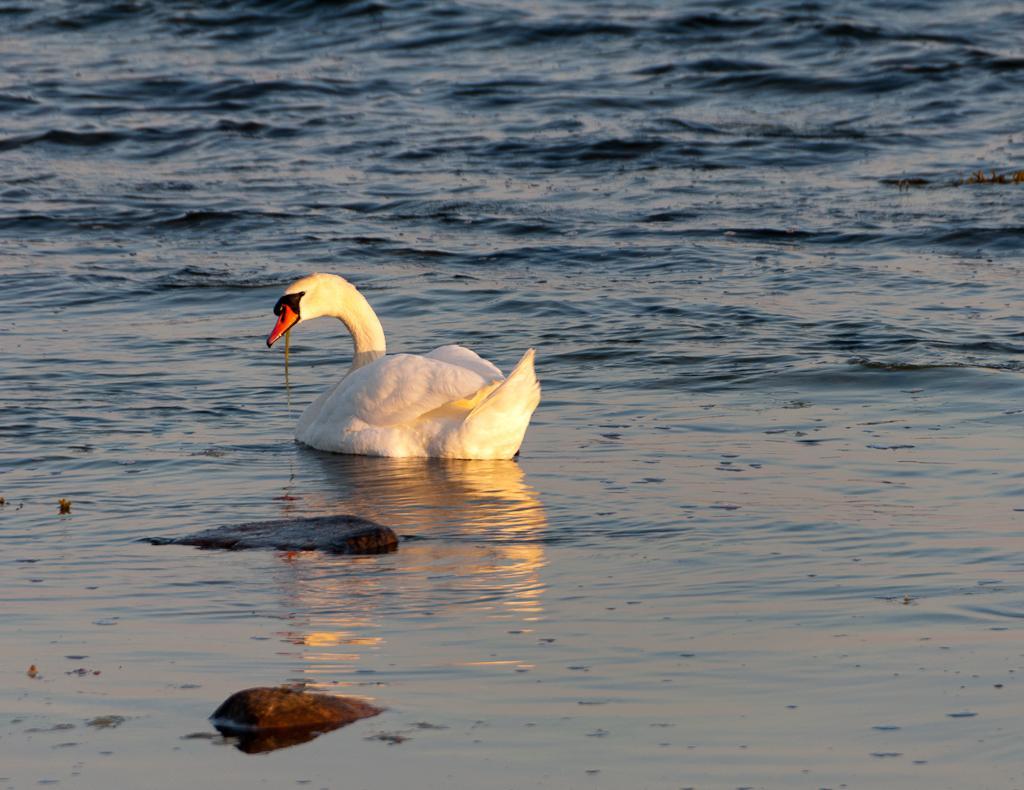Could you give a brief overview of what you see in this image? In the center of the image there is swan. There is water. There are stones. 